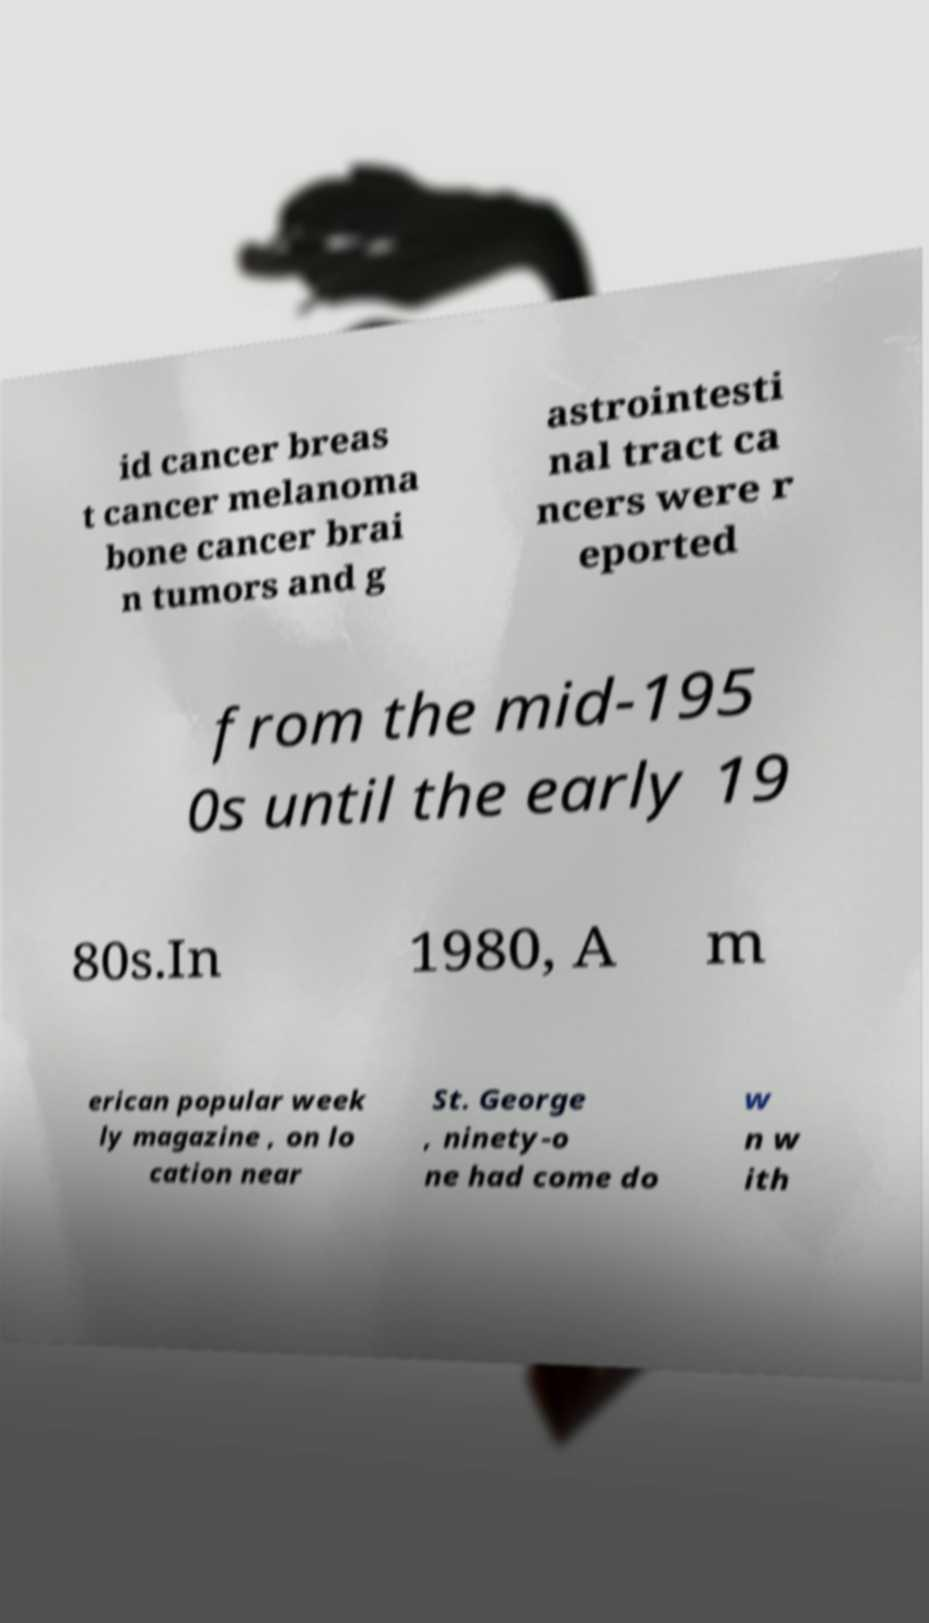Please read and relay the text visible in this image. What does it say? id cancer breas t cancer melanoma bone cancer brai n tumors and g astrointesti nal tract ca ncers were r eported from the mid-195 0s until the early 19 80s.In 1980, A m erican popular week ly magazine , on lo cation near St. George , ninety-o ne had come do w n w ith 